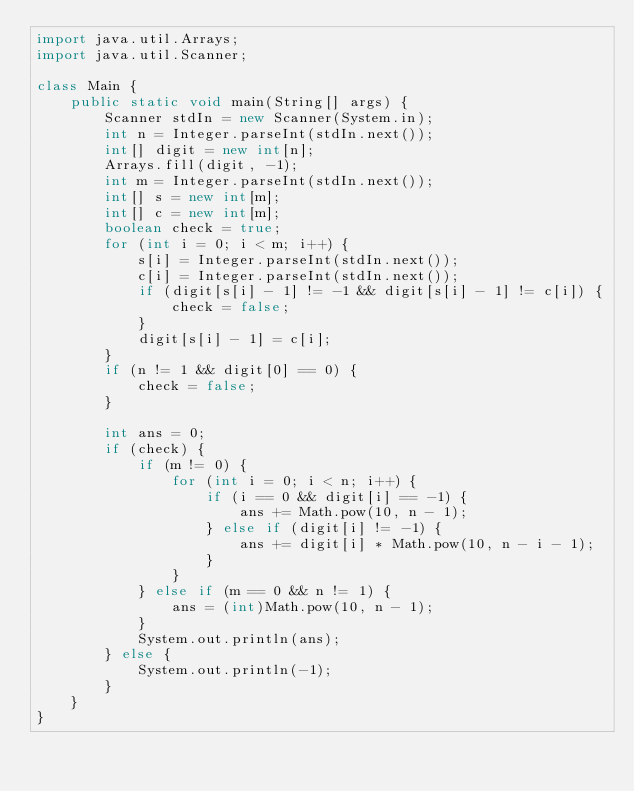Convert code to text. <code><loc_0><loc_0><loc_500><loc_500><_Java_>import java.util.Arrays;
import java.util.Scanner;

class Main {
    public static void main(String[] args) {
        Scanner stdIn = new Scanner(System.in);
        int n = Integer.parseInt(stdIn.next());
        int[] digit = new int[n];
        Arrays.fill(digit, -1);
        int m = Integer.parseInt(stdIn.next());
        int[] s = new int[m];
        int[] c = new int[m];
        boolean check = true;
        for (int i = 0; i < m; i++) {
            s[i] = Integer.parseInt(stdIn.next());
            c[i] = Integer.parseInt(stdIn.next());
            if (digit[s[i] - 1] != -1 && digit[s[i] - 1] != c[i]) {
                check = false;
            }
            digit[s[i] - 1] = c[i];
        }
        if (n != 1 && digit[0] == 0) {
            check = false;
        }

        int ans = 0;
        if (check) {
            if (m != 0) {
                for (int i = 0; i < n; i++) {
                    if (i == 0 && digit[i] == -1) {
                        ans += Math.pow(10, n - 1);
                    } else if (digit[i] != -1) {
                        ans += digit[i] * Math.pow(10, n - i - 1);
                    }
                }
            } else if (m == 0 && n != 1) {
                ans = (int)Math.pow(10, n - 1);
            }
            System.out.println(ans);
        } else {
            System.out.println(-1);
        }
    }
}</code> 